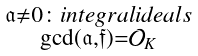<formula> <loc_0><loc_0><loc_500><loc_500>\begin{smallmatrix} \mathfrak { a } \neq 0 \colon i n t e g r a l i d e a l s \\ \gcd ( \mathfrak { a } , \mathfrak { f } ) = \mathcal { O } _ { K } \end{smallmatrix}</formula> 